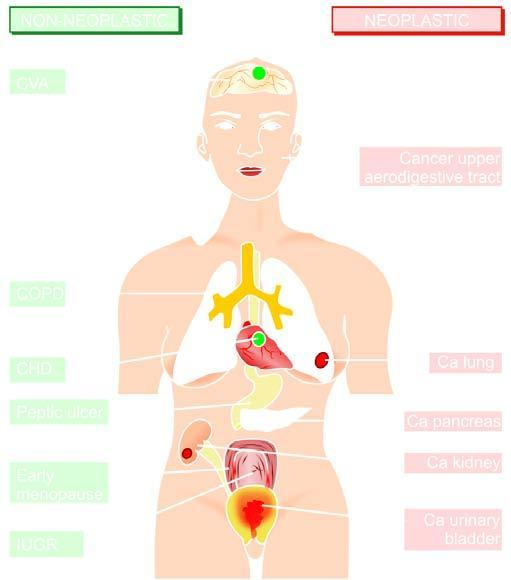s numbers numbered serially in order of frequency of occurrence?
Answer the question using a single word or phrase. No 